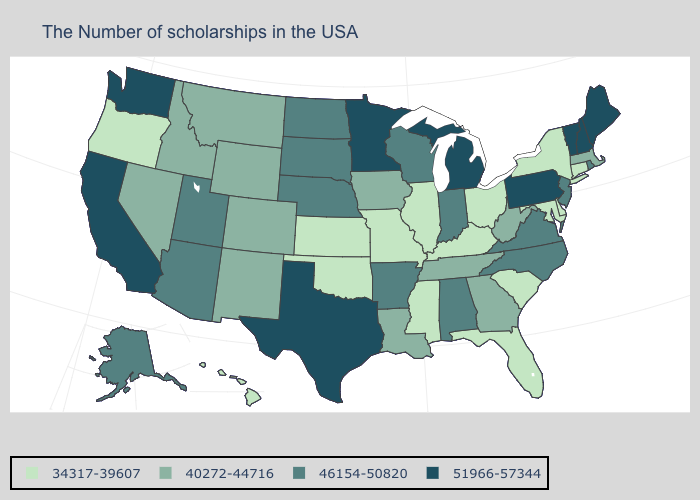Among the states that border Vermont , does New Hampshire have the lowest value?
Give a very brief answer. No. Which states have the lowest value in the USA?
Short answer required. Connecticut, New York, Delaware, Maryland, South Carolina, Ohio, Florida, Kentucky, Illinois, Mississippi, Missouri, Kansas, Oklahoma, Oregon, Hawaii. Name the states that have a value in the range 51966-57344?
Concise answer only. Maine, New Hampshire, Vermont, Pennsylvania, Michigan, Minnesota, Texas, California, Washington. Which states have the lowest value in the USA?
Keep it brief. Connecticut, New York, Delaware, Maryland, South Carolina, Ohio, Florida, Kentucky, Illinois, Mississippi, Missouri, Kansas, Oklahoma, Oregon, Hawaii. Does the map have missing data?
Keep it brief. No. Among the states that border Nevada , which have the lowest value?
Write a very short answer. Oregon. Which states have the highest value in the USA?
Quick response, please. Maine, New Hampshire, Vermont, Pennsylvania, Michigan, Minnesota, Texas, California, Washington. Does the map have missing data?
Be succinct. No. How many symbols are there in the legend?
Answer briefly. 4. Name the states that have a value in the range 51966-57344?
Concise answer only. Maine, New Hampshire, Vermont, Pennsylvania, Michigan, Minnesota, Texas, California, Washington. What is the lowest value in states that border Idaho?
Be succinct. 34317-39607. Which states have the lowest value in the USA?
Write a very short answer. Connecticut, New York, Delaware, Maryland, South Carolina, Ohio, Florida, Kentucky, Illinois, Mississippi, Missouri, Kansas, Oklahoma, Oregon, Hawaii. Name the states that have a value in the range 34317-39607?
Short answer required. Connecticut, New York, Delaware, Maryland, South Carolina, Ohio, Florida, Kentucky, Illinois, Mississippi, Missouri, Kansas, Oklahoma, Oregon, Hawaii. What is the highest value in the USA?
Short answer required. 51966-57344. What is the value of New Hampshire?
Short answer required. 51966-57344. 